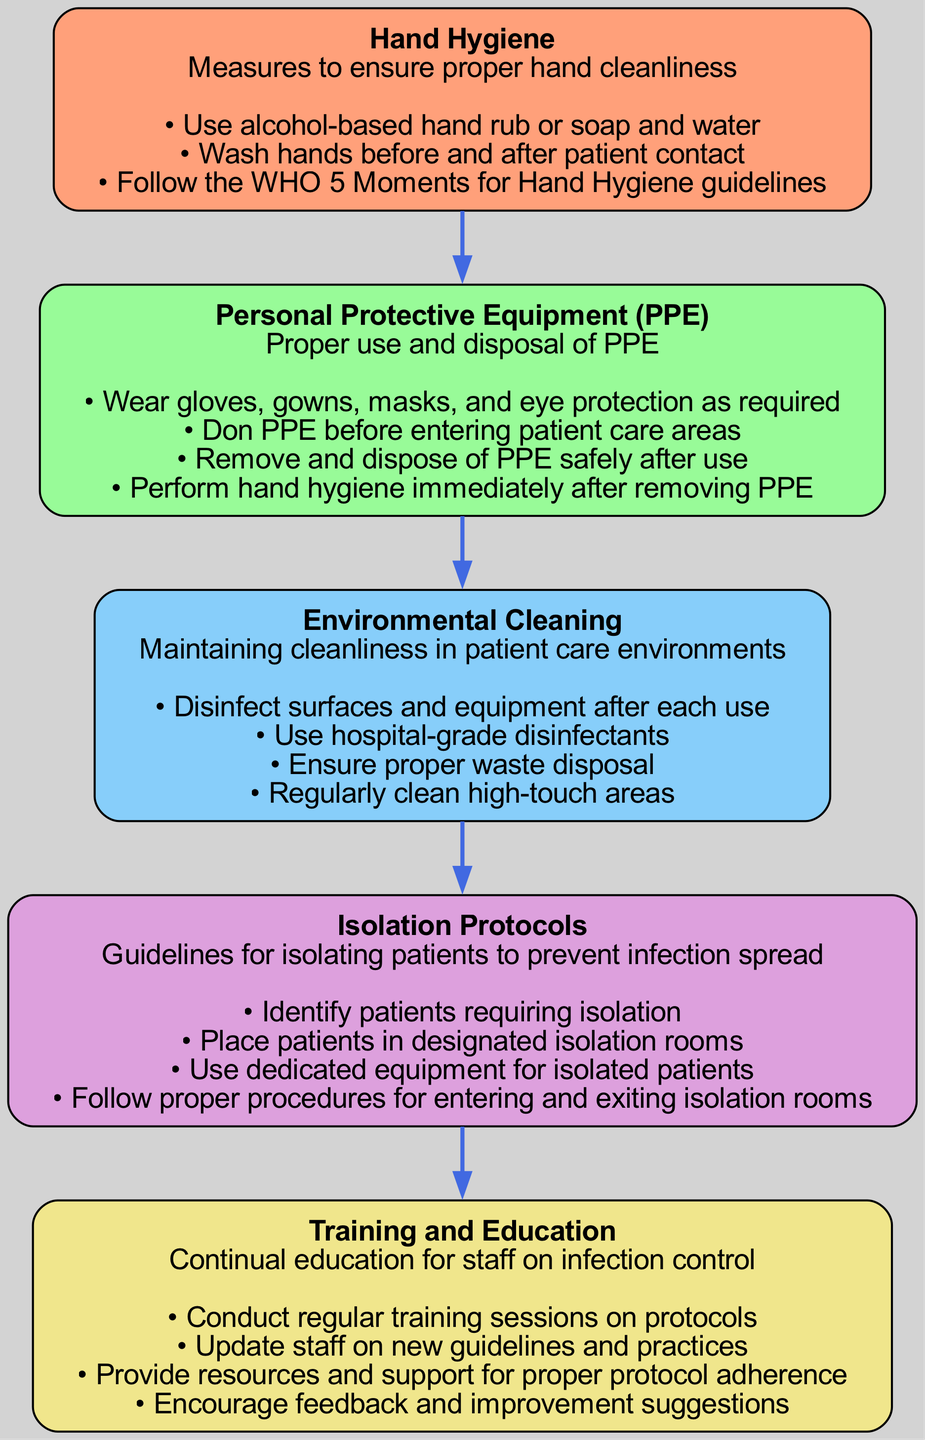What is the first block in the diagram? The first block is "Hand Hygiene". It is the starting point of the flow in the diagram, indicating that hand hygiene practices are the first protocol to be followed in infection control.
Answer: Hand Hygiene How many steps are there in the "Personal Protective Equipment (PPE)" block? There are four steps listed under the "Personal Protective Equipment (PPE)" block. This can be counted directly from the provided information for that specific block.
Answer: 4 What color is the "Environmental Cleaning" block? The "Environmental Cleaning" block is colored light blue, as indicated by the color scheme used for each block in the diagram.
Answer: Light blue What action is recommended immediately after removing PPE? After removing PPE, it is recommended to perform hand hygiene. This is a critical step to ensure that any potential contaminants are removed from the hands.
Answer: Perform hand hygiene Which block follows "Isolation Protocols"? The block that follows "Isolation Protocols" is "Training and Education". This shows the flow of protocols moving from isolation practices to ongoing staff education on infection control.
Answer: Training and Education Are there any steps listed in the "Hand Hygiene" block that reference WHO guidelines? Yes, there is a specific step in the "Hand Hygiene" block that references the WHO 5 Moments for Hand Hygiene guidelines. This indicates adherence to recognized health standards.
Answer: Yes What is the last block in the diagram, and what is its focus? The last block is "Training and Education," focusing on continual education for staff on infection control practices and protocols. This emphasizes the importance of keeping staff updated and informed.
Answer: Training and Education How many nodes are present in the diagram? There are five nodes present in the diagram, one for each block related to infection control protocols. These nodes represent the key components of the overall infection control strategy.
Answer: 5 